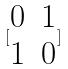<formula> <loc_0><loc_0><loc_500><loc_500>[ \begin{matrix} 0 & 1 \\ 1 & 0 \end{matrix} ]</formula> 